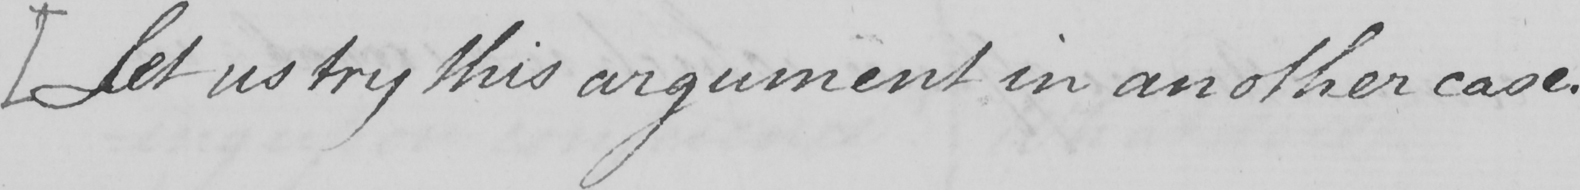Please provide the text content of this handwritten line. [ Let us try this argument in another case . 